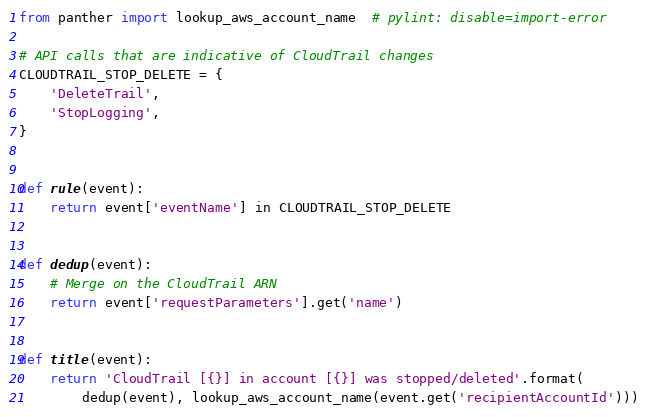Convert code to text. <code><loc_0><loc_0><loc_500><loc_500><_Python_>from panther import lookup_aws_account_name  # pylint: disable=import-error

# API calls that are indicative of CloudTrail changes
CLOUDTRAIL_STOP_DELETE = {
    'DeleteTrail',
    'StopLogging',
}


def rule(event):
    return event['eventName'] in CLOUDTRAIL_STOP_DELETE


def dedup(event):
    # Merge on the CloudTrail ARN
    return event['requestParameters'].get('name')


def title(event):
    return 'CloudTrail [{}] in account [{}] was stopped/deleted'.format(
        dedup(event), lookup_aws_account_name(event.get('recipientAccountId')))
</code> 